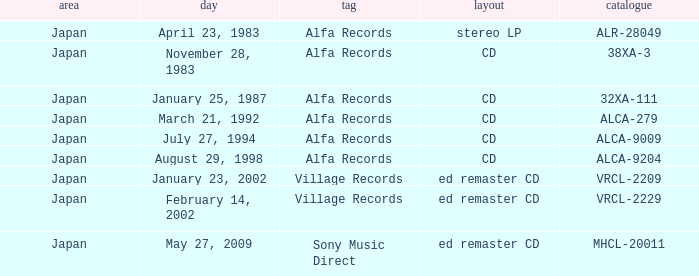What is the format of the date February 14, 2002? Ed remaster cd. 